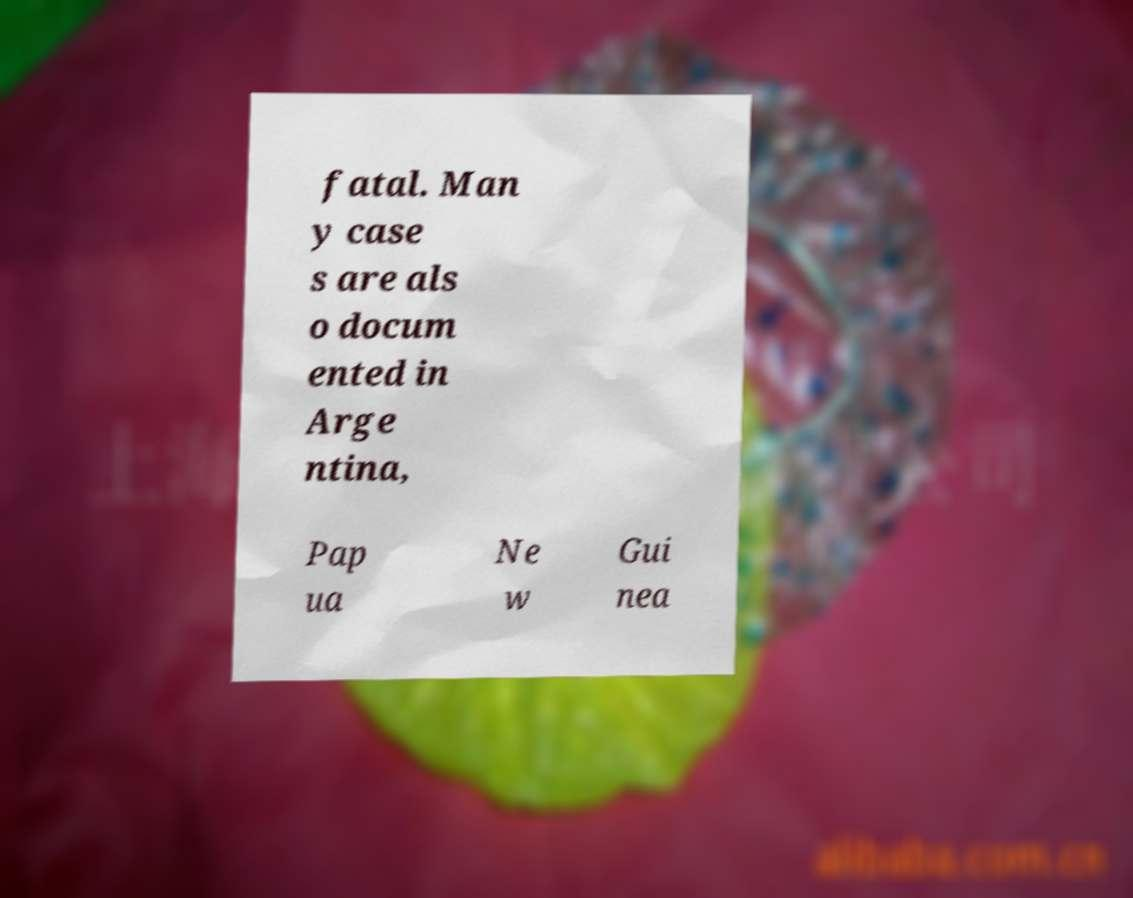There's text embedded in this image that I need extracted. Can you transcribe it verbatim? fatal. Man y case s are als o docum ented in Arge ntina, Pap ua Ne w Gui nea 